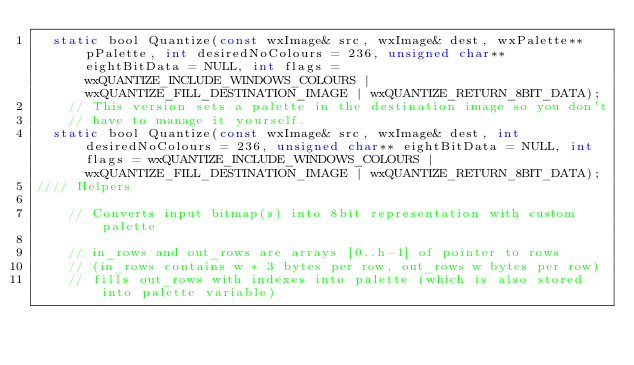Convert code to text. <code><loc_0><loc_0><loc_500><loc_500><_C_>  static bool Quantize(const wxImage& src, wxImage& dest, wxPalette** pPalette, int desiredNoColours = 236, unsigned char** eightBitData = NULL, int flags = wxQUANTIZE_INCLUDE_WINDOWS_COLOURS | wxQUANTIZE_FILL_DESTINATION_IMAGE | wxQUANTIZE_RETURN_8BIT_DATA);
    // This version sets a palette in the destination image so you don't
    // have to manage it yourself.
  static bool Quantize(const wxImage& src, wxImage& dest, int desiredNoColours = 236, unsigned char** eightBitData = NULL, int flags = wxQUANTIZE_INCLUDE_WINDOWS_COLOURS | wxQUANTIZE_FILL_DESTINATION_IMAGE | wxQUANTIZE_RETURN_8BIT_DATA);
//// Helpers

    // Converts input bitmap(s) into 8bit representation with custom palette

    // in_rows and out_rows are arrays [0..h-1] of pointer to rows
    // (in_rows contains w * 3 bytes per row, out_rows w bytes per row)
    // fills out_rows with indexes into palette (which is also stored into palette variable)</code> 